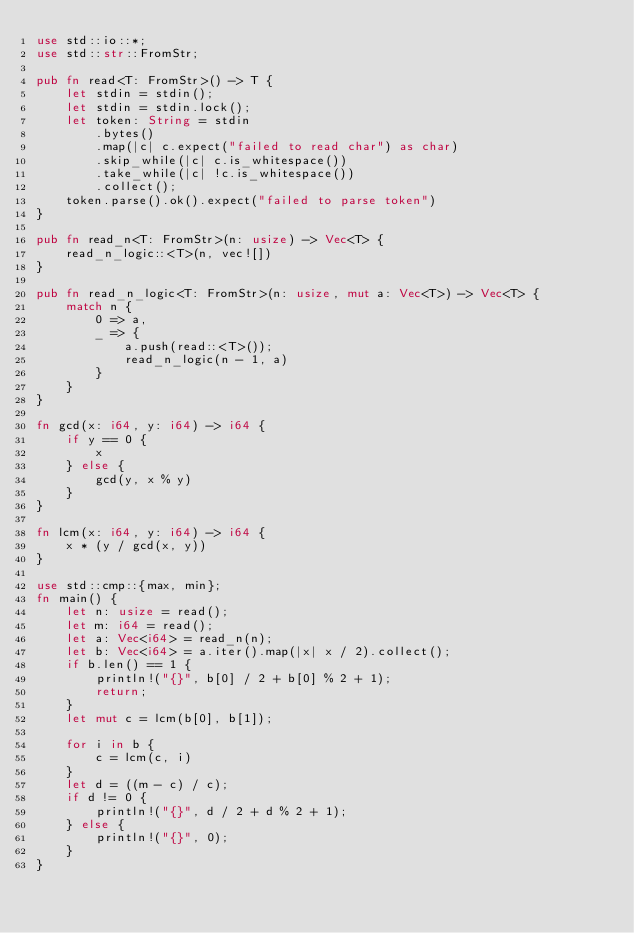Convert code to text. <code><loc_0><loc_0><loc_500><loc_500><_Rust_>use std::io::*;
use std::str::FromStr;

pub fn read<T: FromStr>() -> T {
    let stdin = stdin();
    let stdin = stdin.lock();
    let token: String = stdin
        .bytes()
        .map(|c| c.expect("failed to read char") as char)
        .skip_while(|c| c.is_whitespace())
        .take_while(|c| !c.is_whitespace())
        .collect();
    token.parse().ok().expect("failed to parse token")
}

pub fn read_n<T: FromStr>(n: usize) -> Vec<T> {
    read_n_logic::<T>(n, vec![])
}

pub fn read_n_logic<T: FromStr>(n: usize, mut a: Vec<T>) -> Vec<T> {
    match n {
        0 => a,
        _ => {
            a.push(read::<T>());
            read_n_logic(n - 1, a)
        }
    }
}

fn gcd(x: i64, y: i64) -> i64 {
    if y == 0 {
        x
    } else {
        gcd(y, x % y)
    }
}

fn lcm(x: i64, y: i64) -> i64 {
    x * (y / gcd(x, y))
}

use std::cmp::{max, min};
fn main() {
    let n: usize = read();
    let m: i64 = read();
    let a: Vec<i64> = read_n(n);
    let b: Vec<i64> = a.iter().map(|x| x / 2).collect();
    if b.len() == 1 {
        println!("{}", b[0] / 2 + b[0] % 2 + 1);
        return;
    }
    let mut c = lcm(b[0], b[1]);

    for i in b {
        c = lcm(c, i)
    }
    let d = ((m - c) / c);
    if d != 0 {
        println!("{}", d / 2 + d % 2 + 1);
    } else {
        println!("{}", 0);
    }
}
</code> 